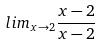<formula> <loc_0><loc_0><loc_500><loc_500>l i m _ { x \rightarrow 2 } \frac { x - 2 } { x - 2 }</formula> 